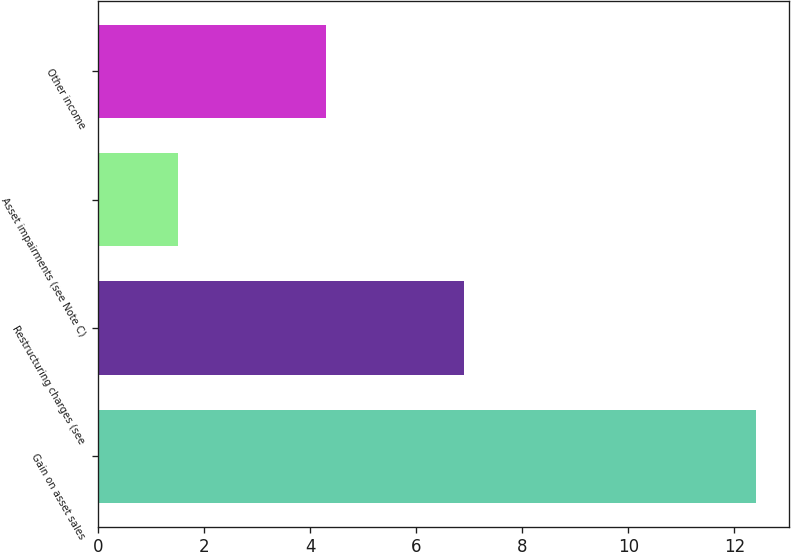<chart> <loc_0><loc_0><loc_500><loc_500><bar_chart><fcel>Gain on asset sales<fcel>Restructuring charges (see<fcel>Asset impairments (see Note C)<fcel>Other income<nl><fcel>12.4<fcel>6.9<fcel>1.5<fcel>4.3<nl></chart> 